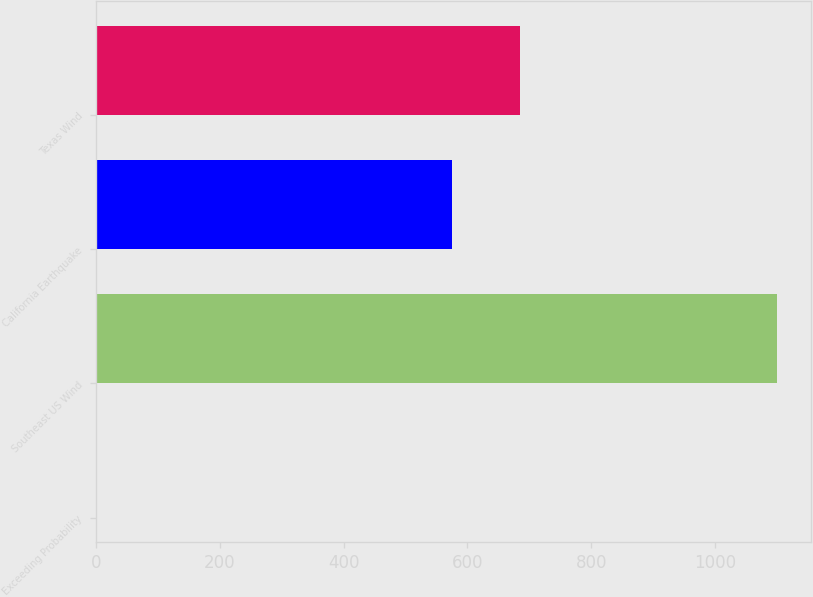Convert chart. <chart><loc_0><loc_0><loc_500><loc_500><bar_chart><fcel>Exceeding Probability<fcel>Southeast US Wind<fcel>California Earthquake<fcel>Texas Wind<nl><fcel>2<fcel>1100<fcel>575<fcel>684.8<nl></chart> 